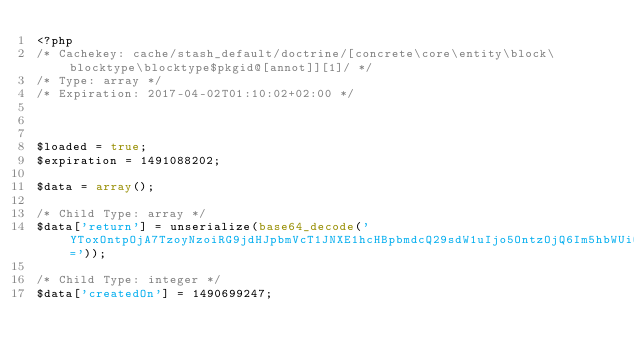<code> <loc_0><loc_0><loc_500><loc_500><_PHP_><?php 
/* Cachekey: cache/stash_default/doctrine/[concrete\core\entity\block\blocktype\blocktype$pkgid@[annot]][1]/ */
/* Type: array */
/* Expiration: 2017-04-02T01:10:02+02:00 */



$loaded = true;
$expiration = 1491088202;

$data = array();

/* Child Type: array */
$data['return'] = unserialize(base64_decode('YToxOntpOjA7TzoyNzoiRG9jdHJpbmVcT1JNXE1hcHBpbmdcQ29sdW1uIjo5OntzOjQ6Im5hbWUiO047czo0OiJ0eXBlIjtzOjc6ImludGVnZXIiO3M6NjoibGVuZ3RoIjtOO3M6OToicHJlY2lzaW9uIjtpOjA7czo1OiJzY2FsZSI7aTowO3M6NjoidW5pcXVlIjtiOjA7czo4OiJudWxsYWJsZSI7YjowO3M6Nzoib3B0aW9ucyI7YToxOntzOjg6InVuc2lnbmVkIjtiOjE7fXM6MTY6ImNvbHVtbkRlZmluaXRpb24iO047fX0='));

/* Child Type: integer */
$data['createdOn'] = 1490699247;
</code> 